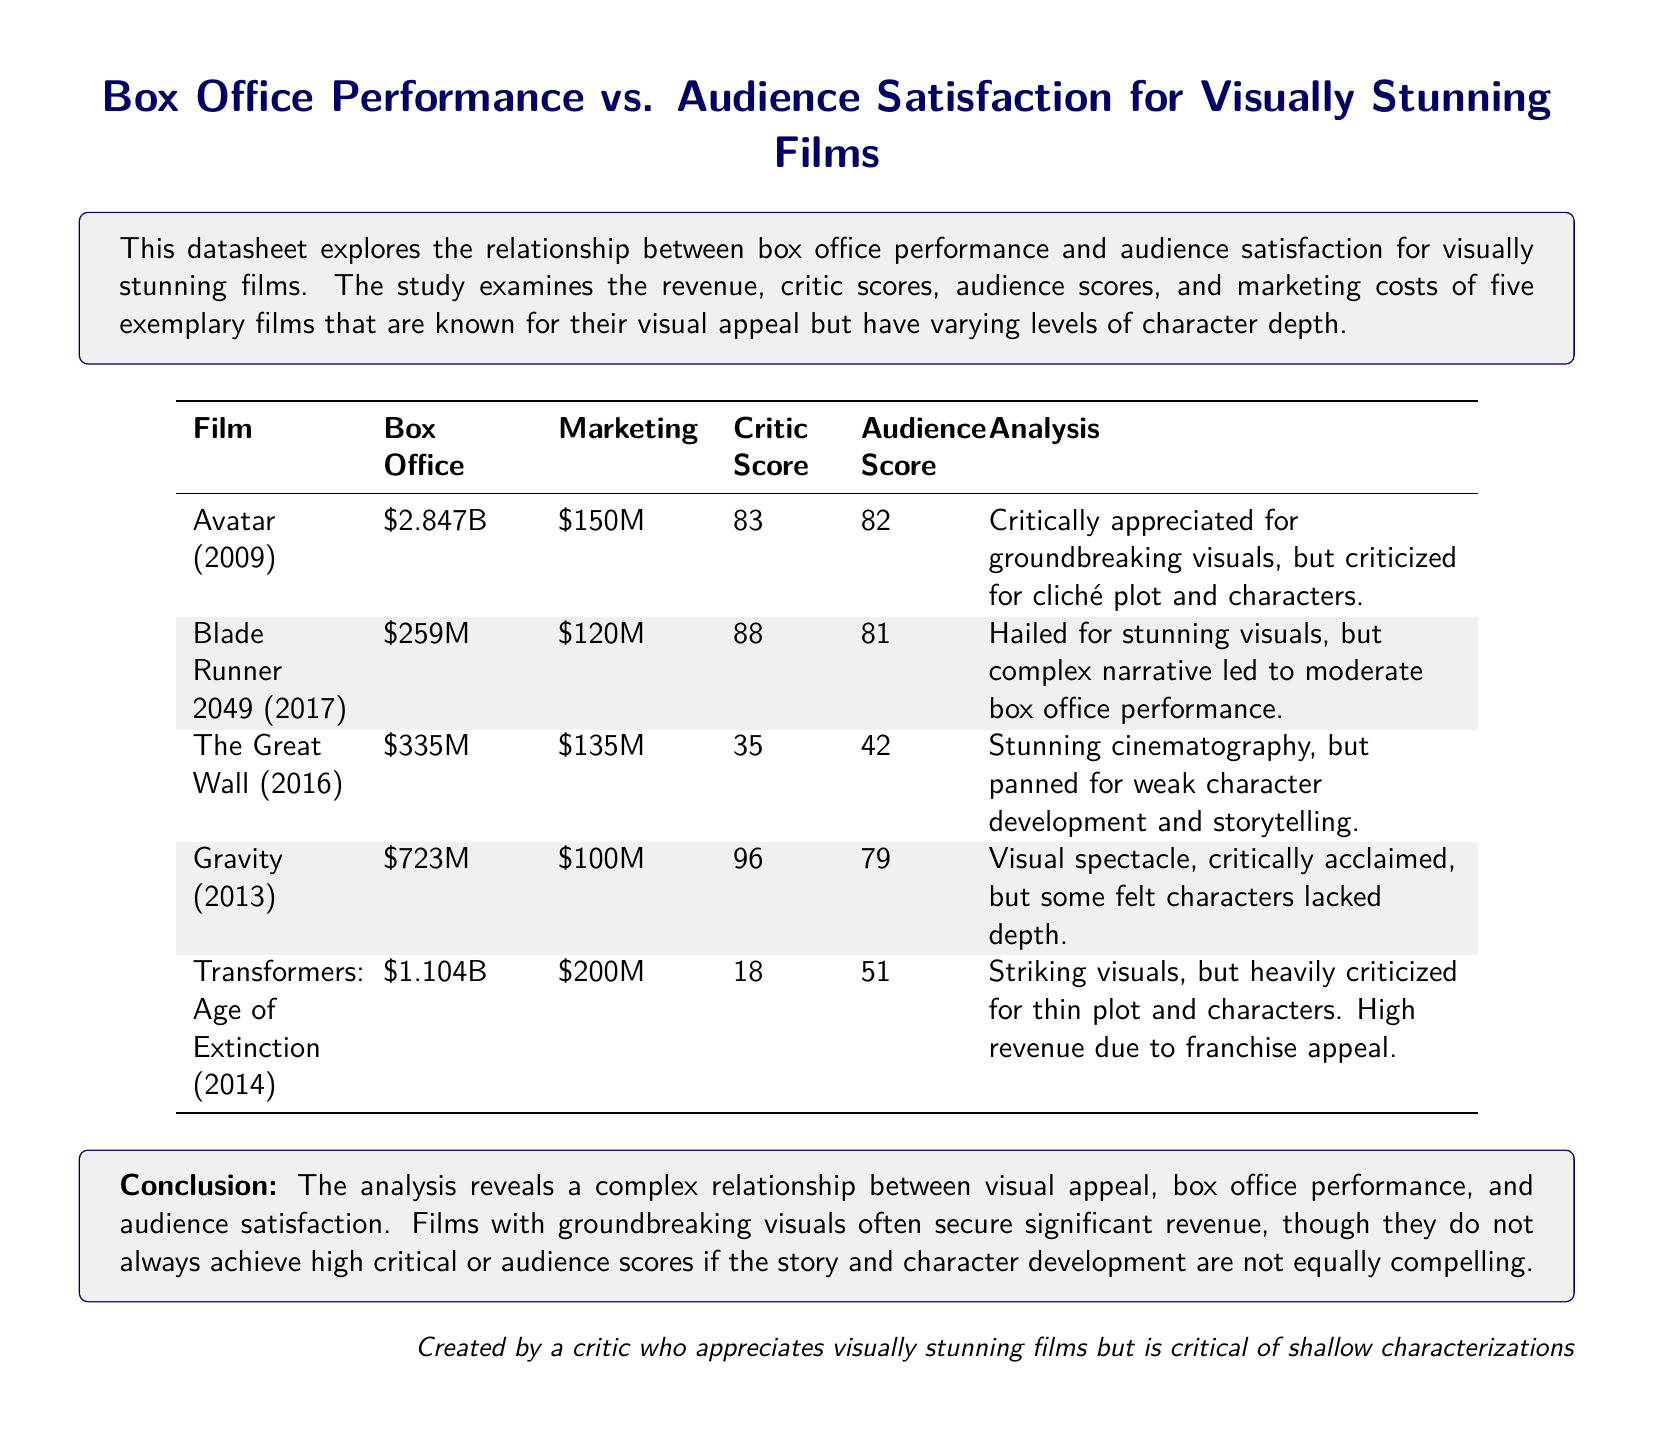What is the box office revenue of Avatar? The box office revenue for Avatar is specified in the table as $2.847B.
Answer: $2.847B What is the marketing cost for Gravity? The marketing cost for Gravity is entered in the table as $100M.
Answer: $100M What is the audience score for Blade Runner 2049? The audience score for Blade Runner 2049 is indicated in the table as 81.
Answer: 81 Which film had the highest critic score? The highest critic score is found in the table and belongs to Gravity with a score of 96.
Answer: 96 What was the revenue for Transformers: Age of Extinction? The revenue for Transformers: Age of Extinction is listed in the table as $1.104B.
Answer: $1.104B Which film was criticized for both visuals and weak character development? The film that was criticized for stunning cinematography but weak character development is The Great Wall.
Answer: The Great Wall What relationship is suggested between visual appeal and box office performance? The document suggests a complex relationship between visual appeal and box office performance, noting significant revenue may not equate to high critical or audience scores.
Answer: Complex relationship Which film is noted for its groundbreaking visuals? The film noted for its groundbreaking visuals is Avatar.
Answer: Avatar What is the primary conclusion of the analysis? The primary conclusion highlights that visual appeal does not always correlate with strong character depth or audience satisfaction.
Answer: Visual appeal does not always correlate with strong character depth or audience satisfaction 